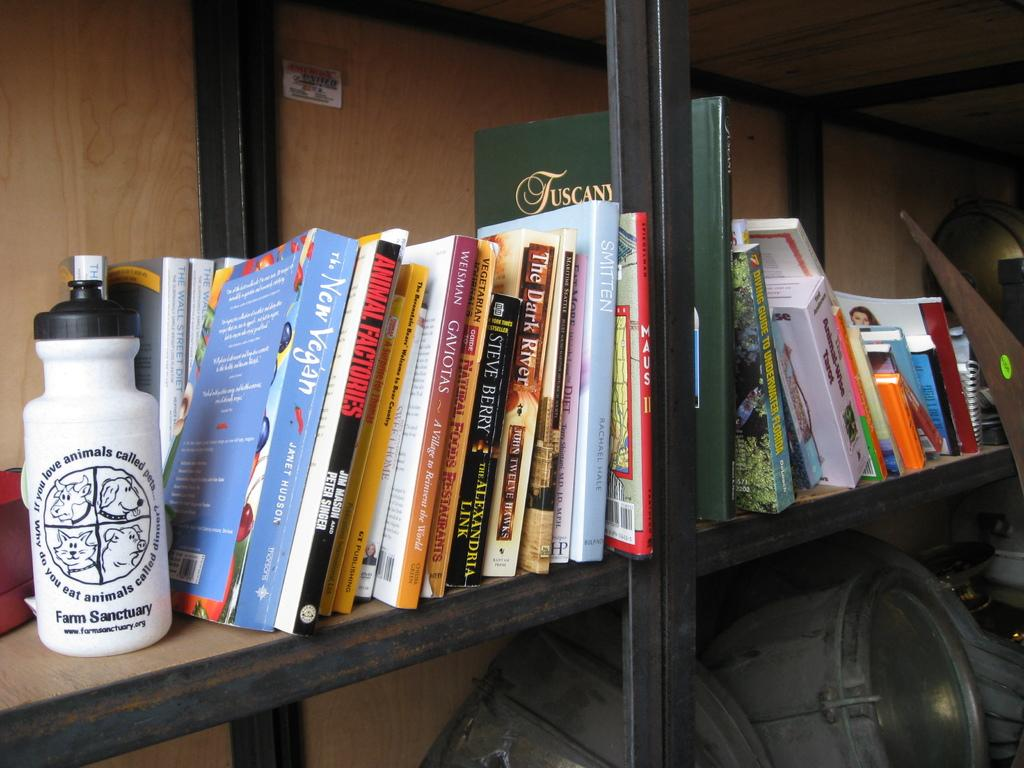<image>
Present a compact description of the photo's key features. A steel frame bookshelf with several books laying haphazardly next to a white Farm Sanctuary water bottle. 